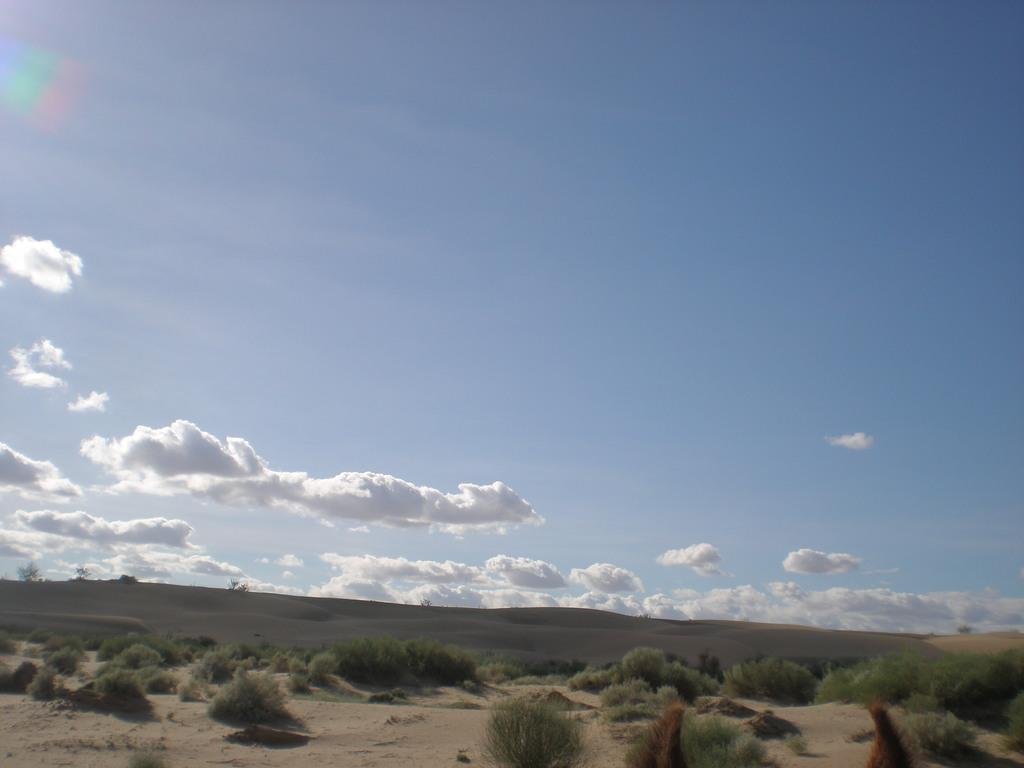What type of living organisms can be seen in the image? Plants can be seen in the image. What color are the plants in the image? The plants are green in color. What is visible in the background of the image? The sky is visible in the background of the image. What colors can be seen in the sky in the image? The sky is blue and white in color. What type of base is used for the game in the image? There is no game or base present in the image; it features plants and a blue and white sky. What can be seen in the can in the image? There is no can present in the image. 